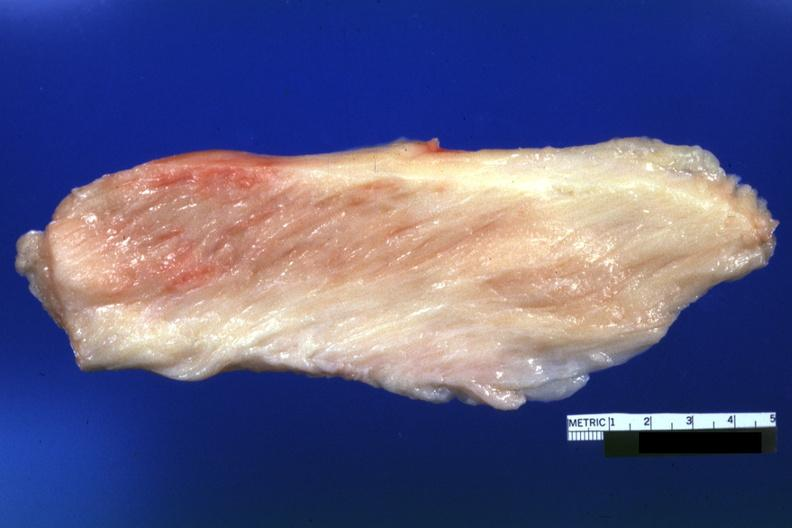s soft tissue present?
Answer the question using a single word or phrase. Yes 